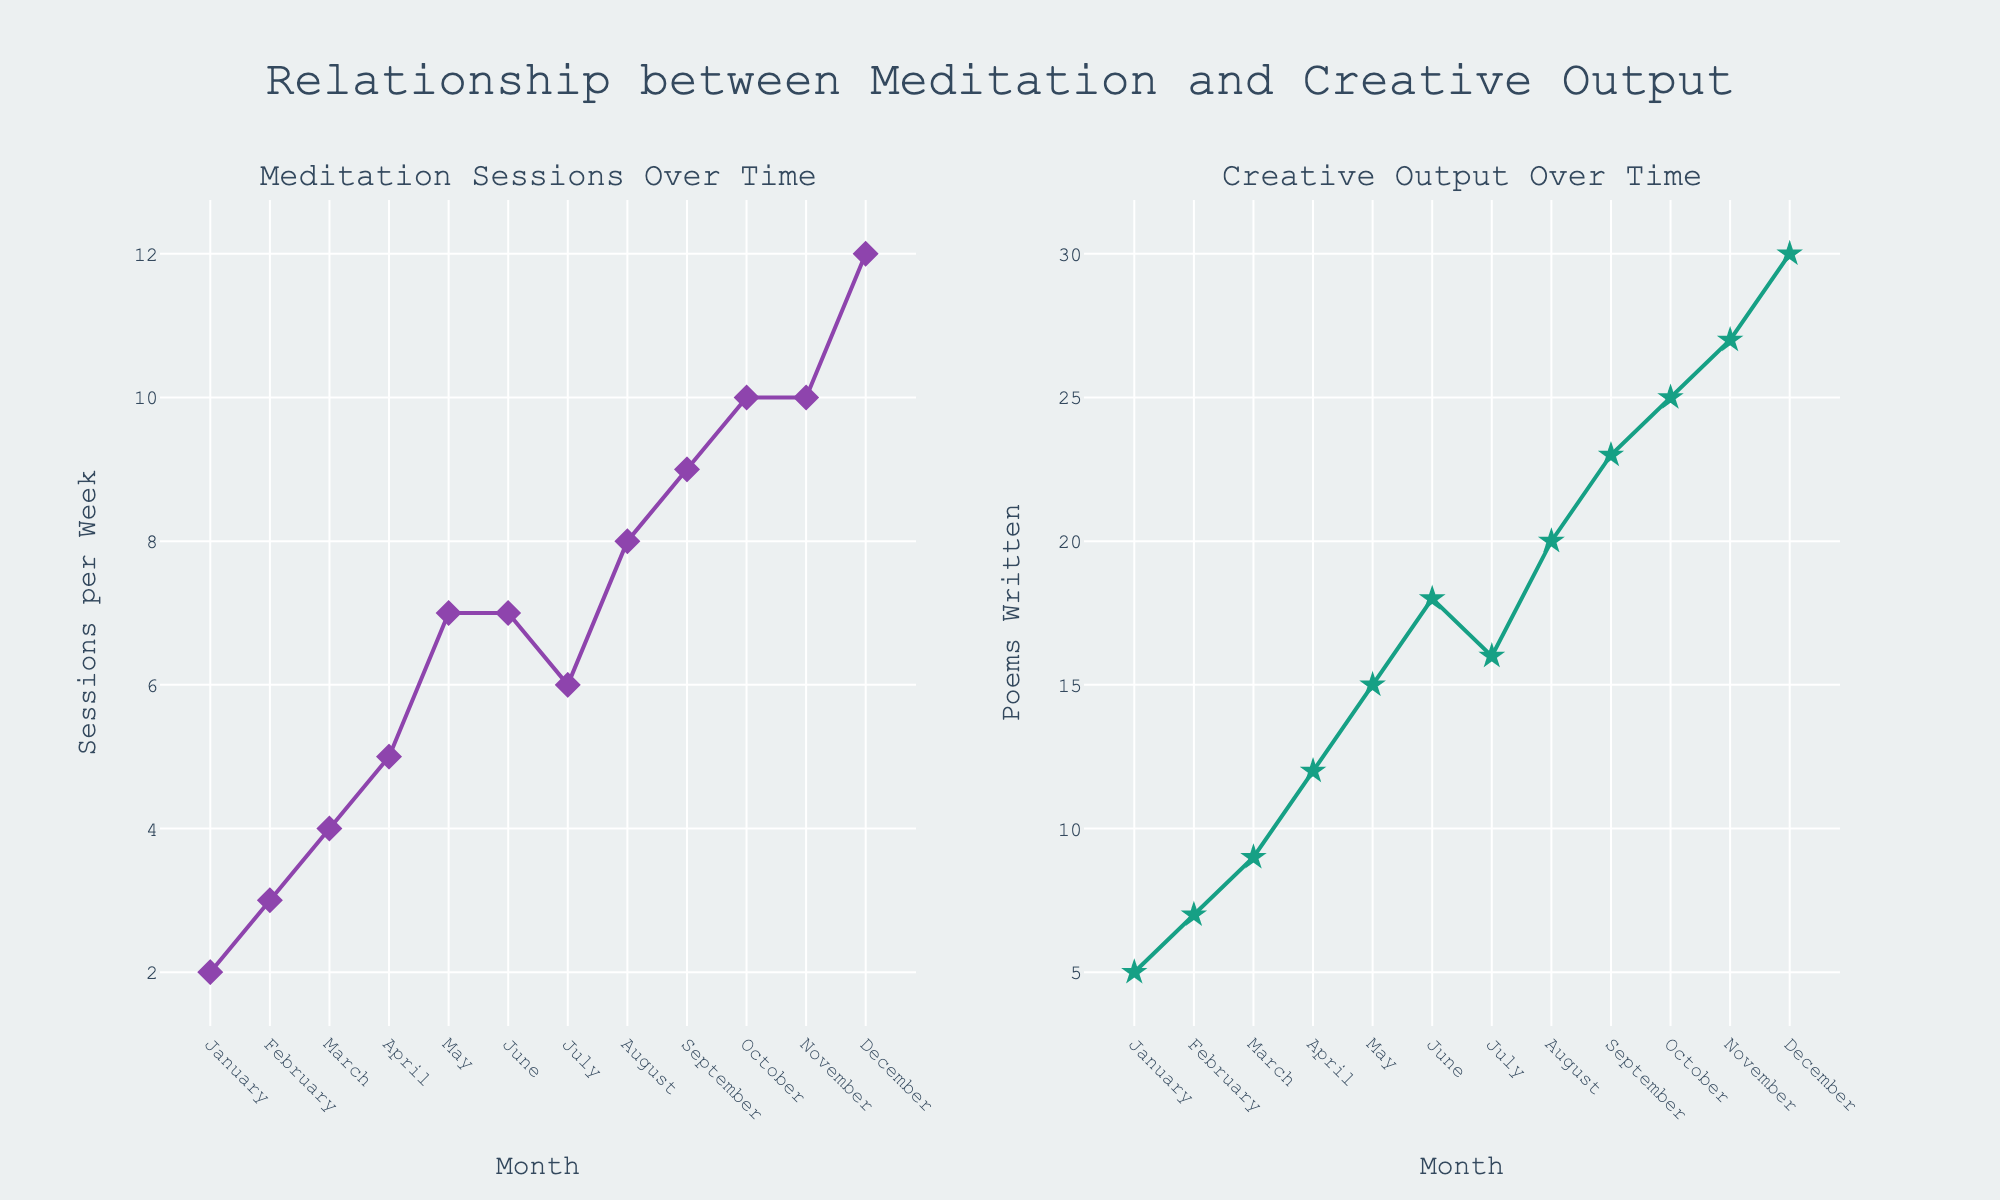What is the title of the figure? The title of the figure is displayed at the top of the plot and reads "Relationship between Meditation and Creative Output".
Answer: Relationship between Meditation and Creative Output How many data points are there in the "Meditation Sessions Over Time" subplot? The data points are marked by the diamond markers in the first subplot. Each month from January to December has one marker, making it 12 data points.
Answer: 12 What is the maximum number of poems written in any month? The maximum number of poems written is represented by the highest star marker on the "Creative Output Over Time" subplot. The label shows it is 30.
Answer: 30 Which month had the highest number of meditation sessions? By looking at the peak diamond marker in the "Meditation Sessions Over Time" subplot, we see that December had the highest number of meditation sessions per week, marked as 12.
Answer: December How did the number of poems written change from April to May? In the "Creative Output Over Time" subplot, April shows 12 poems, and May shows 15. The change is calculated as 15 - 12.
Answer: Increased by 3 What is the general trend in meditation sessions and creative output over the year? Both subplots show an increasing trend over time. The diamond markers for meditation sessions and the star markers for poems written both rise from January to December.
Answer: Increasing Which months had equal numbers of meditation sessions per week? In the "Meditation Sessions Over Time" subplot, we see that the diamond markers for June and July are at the same level (7 sessions per week) and October and November show 10 sessions per week.
Answer: June and July, October and November What is the average number of poems written per month? To find the average, sum the number of poems written each month, then divide by the number of months. Sum = 5 + 7 + 9 + 12 + 15 + 18 + 16 + 20 + 23 + 25 + 27 + 30 = 207. Divide by 12 months.
Answer: 17.25 Did any months show a decrease in the number of poems written? By examining the "Creative Output Over Time" subplot, we notice that the number of poems written remains either increasing or the same throughout the year. No decreases are observed.
Answer: No How does the number of meditation sessions per week in October compare to January? The "Meditation Sessions Over Time" subplot shows October at 10 and January at 2. The difference is calculated as 10 - 2.
Answer: October is 8 sessions higher than January 